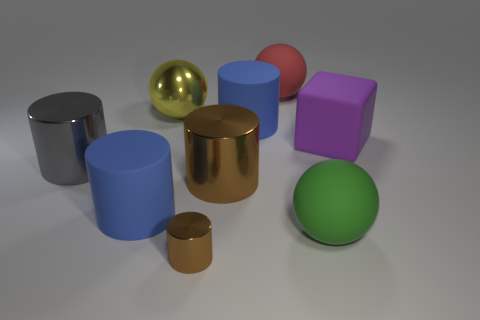There is a rubber ball behind the rubber block that is in front of the large red rubber object; what is its size?
Offer a very short reply. Large. There is a large yellow object that is the same shape as the green object; what material is it?
Ensure brevity in your answer.  Metal. There is a large blue rubber thing that is to the right of the small metallic thing; does it have the same shape as the brown object behind the small brown object?
Offer a very short reply. Yes. Is the number of brown cylinders greater than the number of big red rubber balls?
Give a very brief answer. Yes. The gray thing is what size?
Your answer should be very brief. Large. What number of other things are there of the same color as the tiny object?
Keep it short and to the point. 1. Is the material of the large ball that is in front of the purple cube the same as the purple block?
Your answer should be compact. Yes. Is the number of big cubes that are in front of the big brown shiny thing less than the number of large purple rubber objects on the left side of the tiny brown object?
Your answer should be very brief. No. What number of other things are the same material as the large cube?
Make the answer very short. 4. There is a purple object that is the same size as the red object; what material is it?
Your answer should be compact. Rubber. 